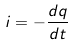<formula> <loc_0><loc_0><loc_500><loc_500>i = - \frac { d q } { d t }</formula> 